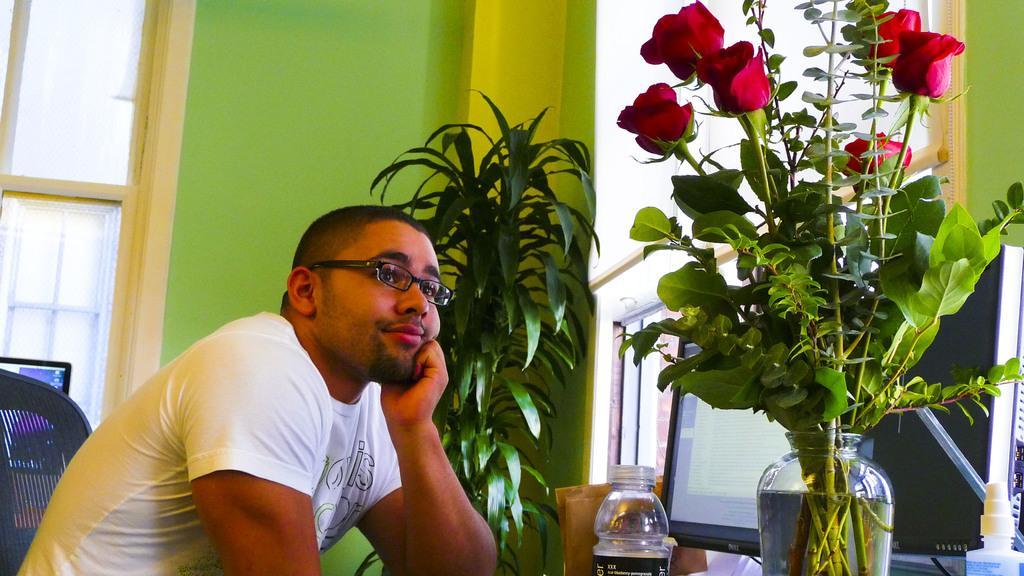Describe this image in one or two sentences. In this picture I can see a person wearing spectacles and sitting on the chair, in front I can see some flower to the potted plants which is placed near the window. 